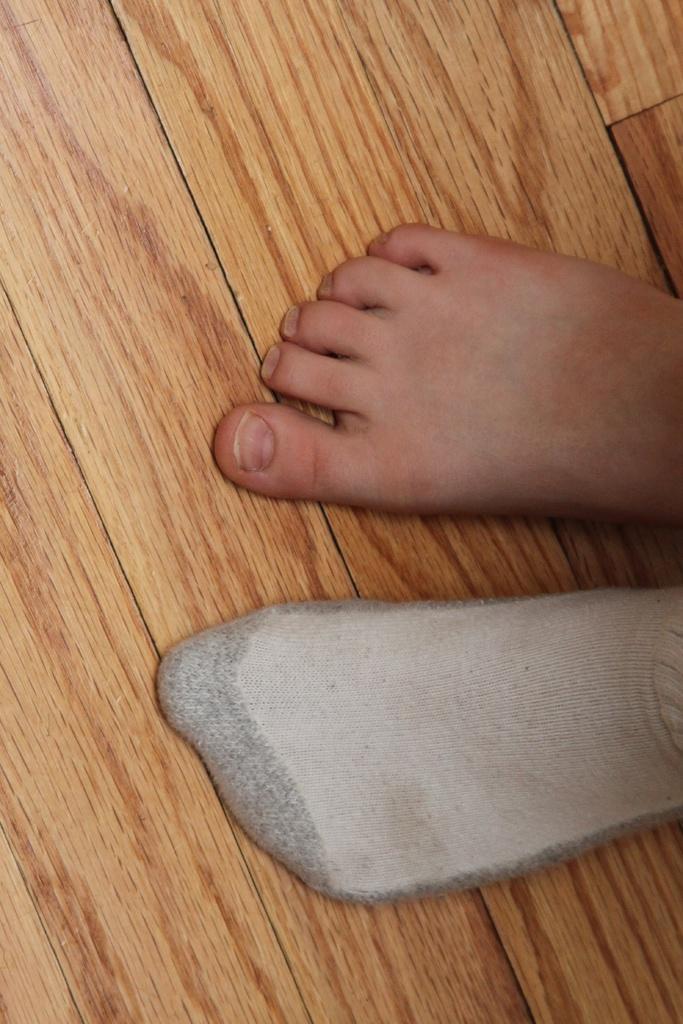Could you give a brief overview of what you see in this image? In this image there is a wooden floor, on that floor there are legs. 